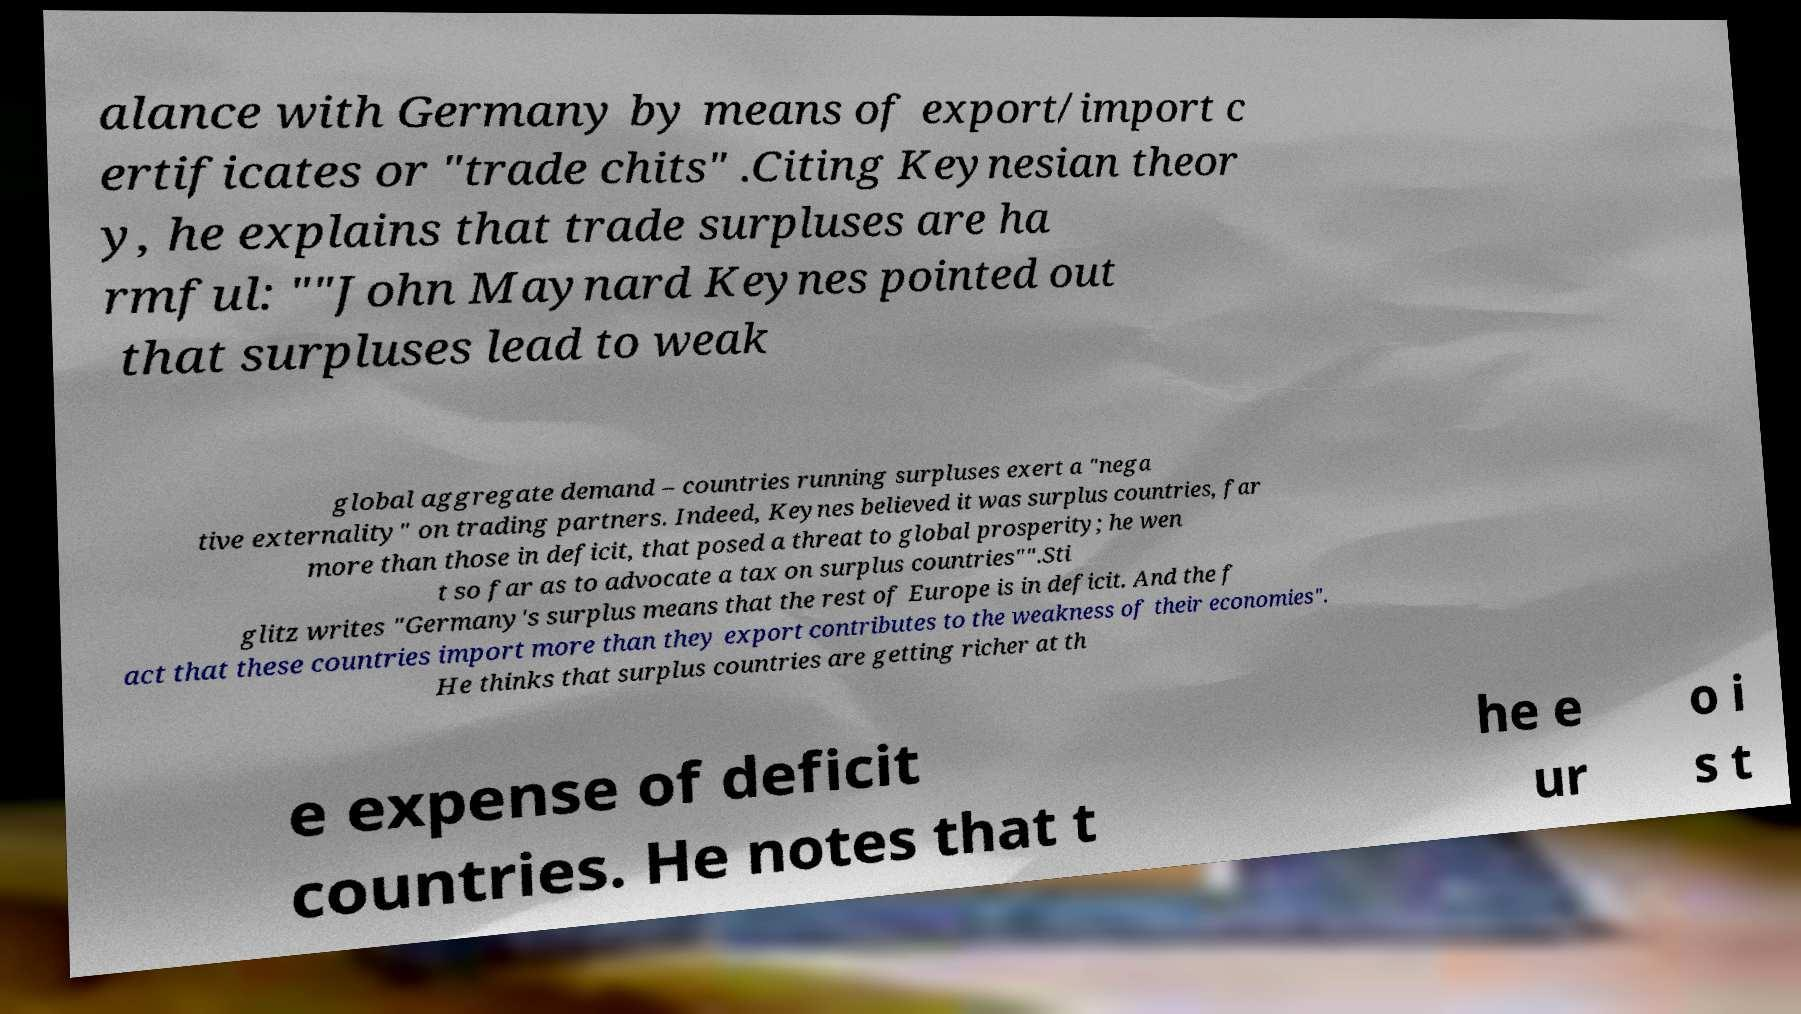There's text embedded in this image that I need extracted. Can you transcribe it verbatim? alance with Germany by means of export/import c ertificates or "trade chits" .Citing Keynesian theor y, he explains that trade surpluses are ha rmful: ""John Maynard Keynes pointed out that surpluses lead to weak global aggregate demand – countries running surpluses exert a "nega tive externality" on trading partners. Indeed, Keynes believed it was surplus countries, far more than those in deficit, that posed a threat to global prosperity; he wen t so far as to advocate a tax on surplus countries"".Sti glitz writes "Germany's surplus means that the rest of Europe is in deficit. And the f act that these countries import more than they export contributes to the weakness of their economies". He thinks that surplus countries are getting richer at th e expense of deficit countries. He notes that t he e ur o i s t 